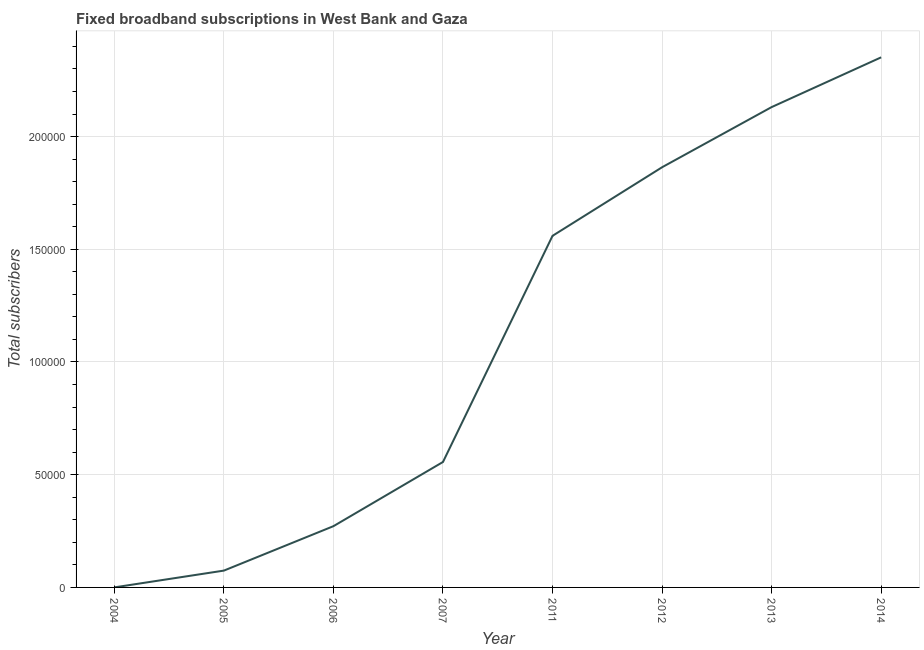What is the total number of fixed broadband subscriptions in 2012?
Provide a short and direct response. 1.86e+05. Across all years, what is the maximum total number of fixed broadband subscriptions?
Your response must be concise. 2.35e+05. Across all years, what is the minimum total number of fixed broadband subscriptions?
Your answer should be compact. 18. In which year was the total number of fixed broadband subscriptions minimum?
Keep it short and to the point. 2004. What is the sum of the total number of fixed broadband subscriptions?
Offer a very short reply. 8.81e+05. What is the difference between the total number of fixed broadband subscriptions in 2006 and 2011?
Offer a terse response. -1.29e+05. What is the average total number of fixed broadband subscriptions per year?
Provide a succinct answer. 1.10e+05. What is the median total number of fixed broadband subscriptions?
Offer a very short reply. 1.06e+05. Do a majority of the years between 2004 and 2005 (inclusive) have total number of fixed broadband subscriptions greater than 20000 ?
Offer a terse response. No. What is the ratio of the total number of fixed broadband subscriptions in 2004 to that in 2012?
Keep it short and to the point. 9.657688593196695e-5. Is the difference between the total number of fixed broadband subscriptions in 2004 and 2006 greater than the difference between any two years?
Provide a short and direct response. No. What is the difference between the highest and the second highest total number of fixed broadband subscriptions?
Ensure brevity in your answer.  2.21e+04. Is the sum of the total number of fixed broadband subscriptions in 2007 and 2014 greater than the maximum total number of fixed broadband subscriptions across all years?
Provide a short and direct response. Yes. What is the difference between the highest and the lowest total number of fixed broadband subscriptions?
Your answer should be very brief. 2.35e+05. In how many years, is the total number of fixed broadband subscriptions greater than the average total number of fixed broadband subscriptions taken over all years?
Your response must be concise. 4. Does the total number of fixed broadband subscriptions monotonically increase over the years?
Give a very brief answer. Yes. How many years are there in the graph?
Offer a terse response. 8. Does the graph contain grids?
Your answer should be very brief. Yes. What is the title of the graph?
Give a very brief answer. Fixed broadband subscriptions in West Bank and Gaza. What is the label or title of the Y-axis?
Offer a terse response. Total subscribers. What is the Total subscribers in 2005?
Keep it short and to the point. 7463. What is the Total subscribers of 2006?
Make the answer very short. 2.72e+04. What is the Total subscribers of 2007?
Ensure brevity in your answer.  5.56e+04. What is the Total subscribers in 2011?
Offer a terse response. 1.56e+05. What is the Total subscribers in 2012?
Your answer should be very brief. 1.86e+05. What is the Total subscribers in 2013?
Offer a terse response. 2.13e+05. What is the Total subscribers of 2014?
Give a very brief answer. 2.35e+05. What is the difference between the Total subscribers in 2004 and 2005?
Provide a succinct answer. -7445. What is the difference between the Total subscribers in 2004 and 2006?
Offer a terse response. -2.72e+04. What is the difference between the Total subscribers in 2004 and 2007?
Offer a terse response. -5.56e+04. What is the difference between the Total subscribers in 2004 and 2011?
Offer a terse response. -1.56e+05. What is the difference between the Total subscribers in 2004 and 2012?
Offer a terse response. -1.86e+05. What is the difference between the Total subscribers in 2004 and 2013?
Ensure brevity in your answer.  -2.13e+05. What is the difference between the Total subscribers in 2004 and 2014?
Keep it short and to the point. -2.35e+05. What is the difference between the Total subscribers in 2005 and 2006?
Your answer should be very brief. -1.97e+04. What is the difference between the Total subscribers in 2005 and 2007?
Your answer should be compact. -4.82e+04. What is the difference between the Total subscribers in 2005 and 2011?
Offer a very short reply. -1.49e+05. What is the difference between the Total subscribers in 2005 and 2012?
Keep it short and to the point. -1.79e+05. What is the difference between the Total subscribers in 2005 and 2013?
Offer a very short reply. -2.06e+05. What is the difference between the Total subscribers in 2005 and 2014?
Give a very brief answer. -2.28e+05. What is the difference between the Total subscribers in 2006 and 2007?
Ensure brevity in your answer.  -2.85e+04. What is the difference between the Total subscribers in 2006 and 2011?
Your response must be concise. -1.29e+05. What is the difference between the Total subscribers in 2006 and 2012?
Make the answer very short. -1.59e+05. What is the difference between the Total subscribers in 2006 and 2013?
Keep it short and to the point. -1.86e+05. What is the difference between the Total subscribers in 2006 and 2014?
Provide a short and direct response. -2.08e+05. What is the difference between the Total subscribers in 2007 and 2011?
Provide a short and direct response. -1.00e+05. What is the difference between the Total subscribers in 2007 and 2012?
Ensure brevity in your answer.  -1.31e+05. What is the difference between the Total subscribers in 2007 and 2013?
Ensure brevity in your answer.  -1.57e+05. What is the difference between the Total subscribers in 2007 and 2014?
Provide a short and direct response. -1.79e+05. What is the difference between the Total subscribers in 2011 and 2012?
Give a very brief answer. -3.04e+04. What is the difference between the Total subscribers in 2011 and 2013?
Make the answer very short. -5.71e+04. What is the difference between the Total subscribers in 2011 and 2014?
Offer a terse response. -7.92e+04. What is the difference between the Total subscribers in 2012 and 2013?
Your response must be concise. -2.67e+04. What is the difference between the Total subscribers in 2012 and 2014?
Your response must be concise. -4.88e+04. What is the difference between the Total subscribers in 2013 and 2014?
Keep it short and to the point. -2.21e+04. What is the ratio of the Total subscribers in 2004 to that in 2005?
Provide a short and direct response. 0. What is the ratio of the Total subscribers in 2004 to that in 2006?
Make the answer very short. 0. What is the ratio of the Total subscribers in 2005 to that in 2006?
Your response must be concise. 0.28. What is the ratio of the Total subscribers in 2005 to that in 2007?
Offer a terse response. 0.13. What is the ratio of the Total subscribers in 2005 to that in 2011?
Ensure brevity in your answer.  0.05. What is the ratio of the Total subscribers in 2005 to that in 2012?
Give a very brief answer. 0.04. What is the ratio of the Total subscribers in 2005 to that in 2013?
Provide a short and direct response. 0.04. What is the ratio of the Total subscribers in 2005 to that in 2014?
Your response must be concise. 0.03. What is the ratio of the Total subscribers in 2006 to that in 2007?
Give a very brief answer. 0.49. What is the ratio of the Total subscribers in 2006 to that in 2011?
Make the answer very short. 0.17. What is the ratio of the Total subscribers in 2006 to that in 2012?
Give a very brief answer. 0.15. What is the ratio of the Total subscribers in 2006 to that in 2013?
Offer a terse response. 0.13. What is the ratio of the Total subscribers in 2006 to that in 2014?
Ensure brevity in your answer.  0.12. What is the ratio of the Total subscribers in 2007 to that in 2011?
Provide a short and direct response. 0.36. What is the ratio of the Total subscribers in 2007 to that in 2012?
Your answer should be very brief. 0.3. What is the ratio of the Total subscribers in 2007 to that in 2013?
Provide a short and direct response. 0.26. What is the ratio of the Total subscribers in 2007 to that in 2014?
Make the answer very short. 0.24. What is the ratio of the Total subscribers in 2011 to that in 2012?
Ensure brevity in your answer.  0.84. What is the ratio of the Total subscribers in 2011 to that in 2013?
Make the answer very short. 0.73. What is the ratio of the Total subscribers in 2011 to that in 2014?
Your answer should be compact. 0.66. What is the ratio of the Total subscribers in 2012 to that in 2014?
Offer a terse response. 0.79. What is the ratio of the Total subscribers in 2013 to that in 2014?
Offer a terse response. 0.91. 